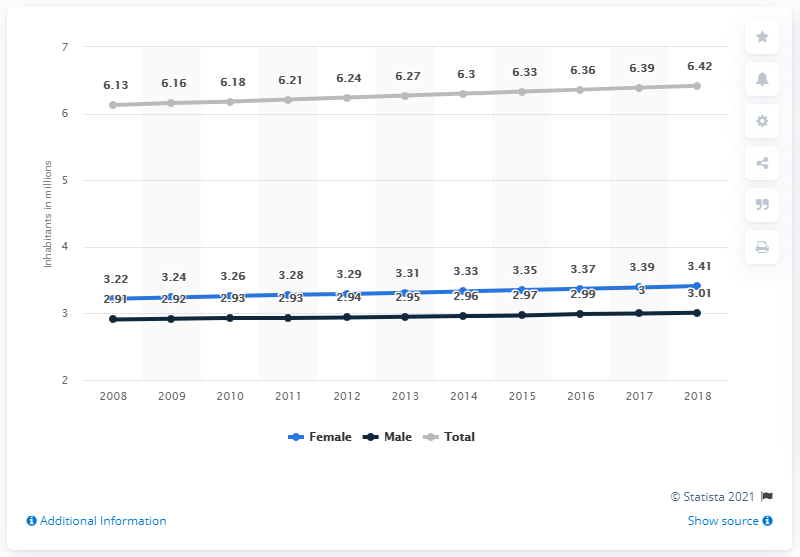What information does this chart provide about the population trends from 2008 to 2018? The chart illustrates the population trends in El Salvador from 2008 to 2018, detailing the male, female, and total population each year. Significant observations include a gradual increase in both genders' populations over the decade, with the total population seeing a steady rise. 